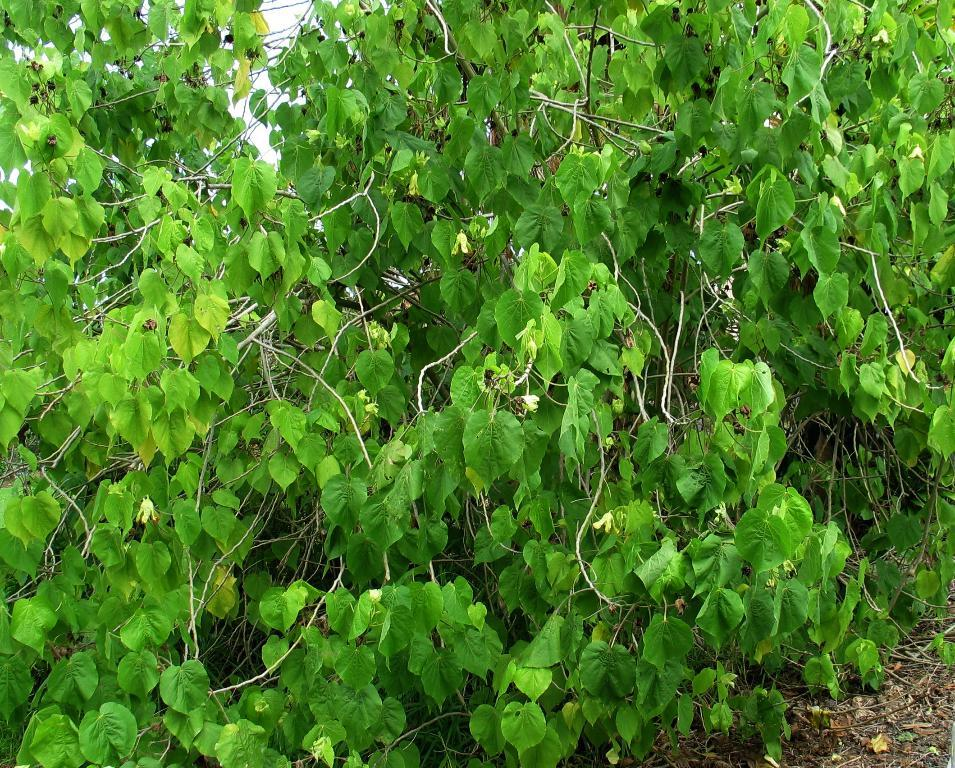What type of living organisms can be seen in the image? Plants can be seen in the image. How many steps are visible in the image? There are no steps present in the image; it only contains plants. What type of material is the brick used for the home in the image? There is no home or brick present in the image; it only contains plants. 